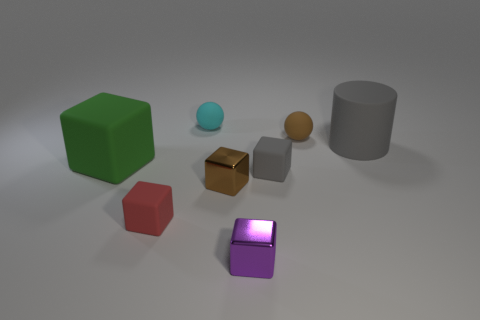Subtract all brown blocks. How many blocks are left? 4 Subtract all small purple shiny cubes. How many cubes are left? 4 Subtract all red blocks. Subtract all purple spheres. How many blocks are left? 4 Add 2 small brown cylinders. How many objects exist? 10 Subtract all spheres. How many objects are left? 6 Add 3 brown metallic blocks. How many brown metallic blocks exist? 4 Subtract 1 gray blocks. How many objects are left? 7 Subtract all large green matte things. Subtract all tiny brown objects. How many objects are left? 5 Add 7 gray matte cylinders. How many gray matte cylinders are left? 8 